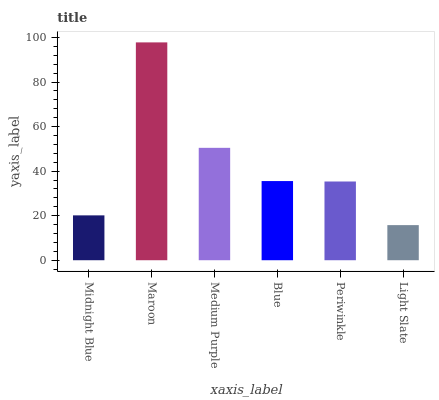Is Light Slate the minimum?
Answer yes or no. Yes. Is Maroon the maximum?
Answer yes or no. Yes. Is Medium Purple the minimum?
Answer yes or no. No. Is Medium Purple the maximum?
Answer yes or no. No. Is Maroon greater than Medium Purple?
Answer yes or no. Yes. Is Medium Purple less than Maroon?
Answer yes or no. Yes. Is Medium Purple greater than Maroon?
Answer yes or no. No. Is Maroon less than Medium Purple?
Answer yes or no. No. Is Blue the high median?
Answer yes or no. Yes. Is Periwinkle the low median?
Answer yes or no. Yes. Is Periwinkle the high median?
Answer yes or no. No. Is Blue the low median?
Answer yes or no. No. 